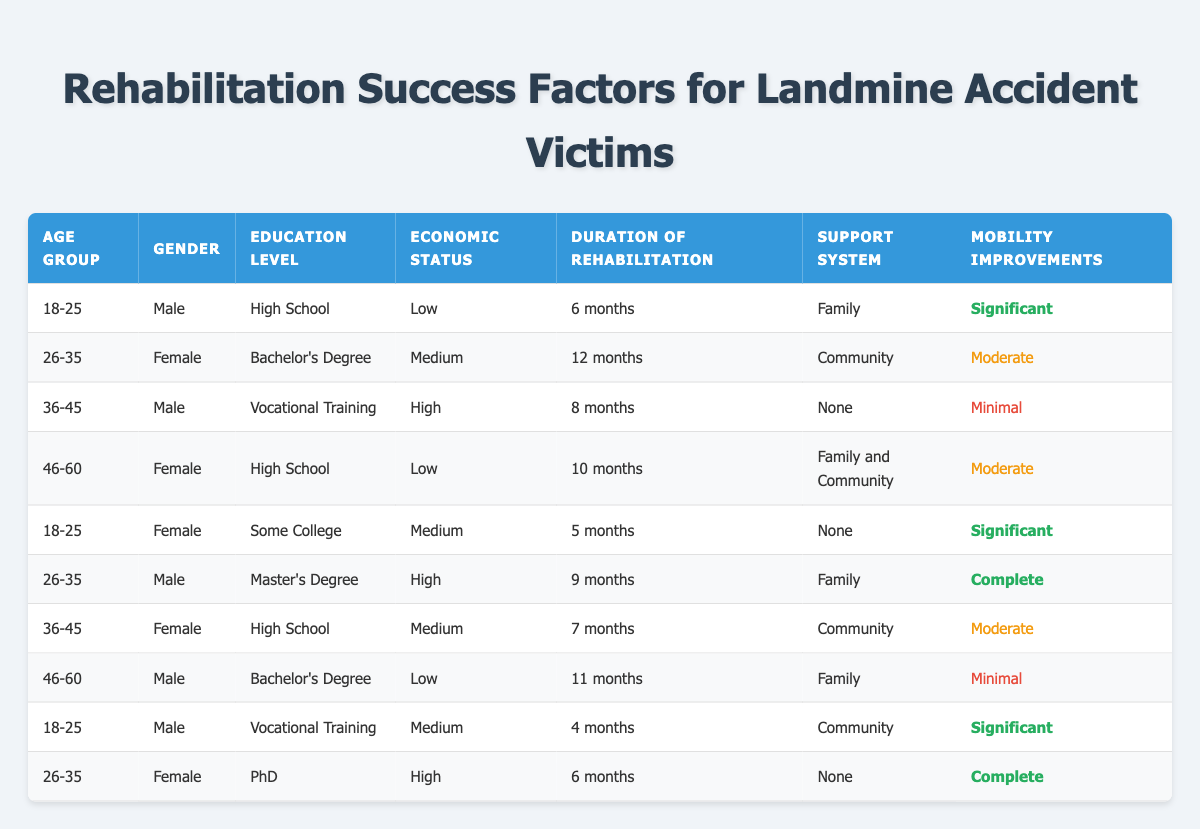What is the mobility improvement for individuals aged 36-45 with a Bachelor's Degree? In the table, the only record for the age group 36-45 with a Bachelor's Degree is for a Male who has Minimal mobility improvements.
Answer: Minimal How many individuals in the age group 26-35 had a Master's Degree? There is only one individual in the table with the age group 26-35 and a Master's Degree, and that individual experienced Complete mobility improvements.
Answer: 1 What is the average duration of rehabilitation for individuals who experienced Significant mobility improvements? The durations for significant mobility improvements are 6 months, 5 months, and 4 months. The sum is (6 + 5 + 4) = 15 months. The average is 15/3 = 5 months.
Answer: 5 months Is there an individual aged 46-60 who experienced Complete mobility improvements? Reviewing all entries for the age group 46-60 in the table, none of them indicate a Complete mobility improvement; they all show Moderate or Minimal.
Answer: No Which support system correlated with the highest rate of mobility improvements? The highest rates of mobility improvement were Significantly and Complete. The individuals with Significant improvement had support from Family or Community, while the Complete improvement was also with Family. Therefore, both Family and Community support systems correlated with high improvements.
Answer: Family and Community 